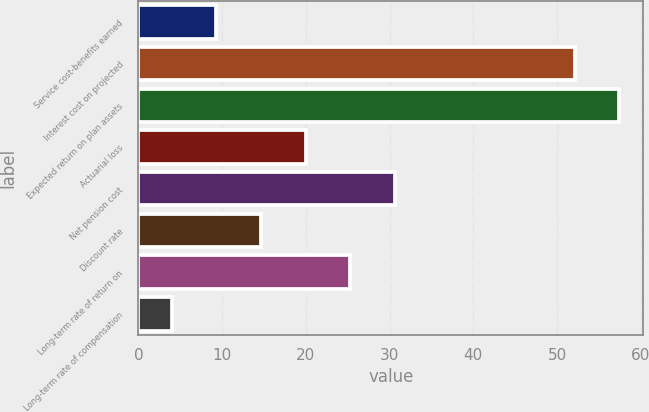Convert chart to OTSL. <chart><loc_0><loc_0><loc_500><loc_500><bar_chart><fcel>Service cost-benefits earned<fcel>Interest cost on projected<fcel>Expected return on plan assets<fcel>Actuarial loss<fcel>Net pension cost<fcel>Discount rate<fcel>Long-term rate of return on<fcel>Long-term rate of compensation<nl><fcel>9.32<fcel>52.1<fcel>57.42<fcel>19.96<fcel>30.6<fcel>14.64<fcel>25.28<fcel>4<nl></chart> 